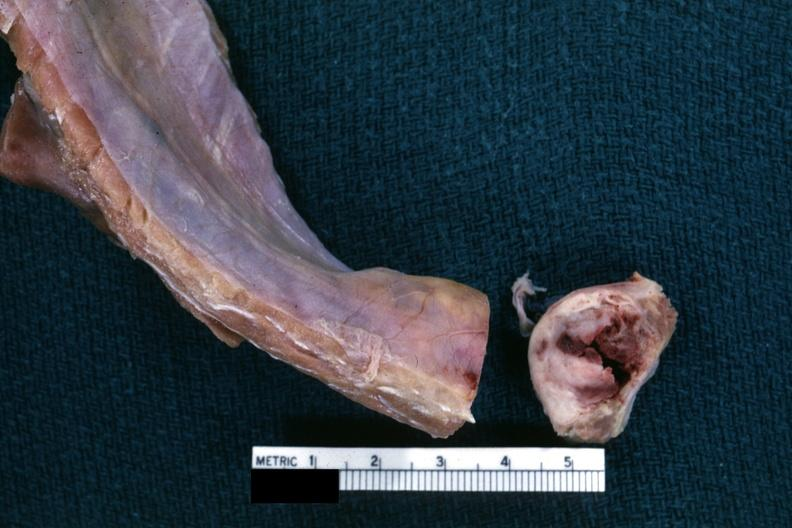what does this image show?
Answer the question using a single word or phrase. Obvious nodular rib lesion cross sectioned to show white neoplasm with central hemorrhage 